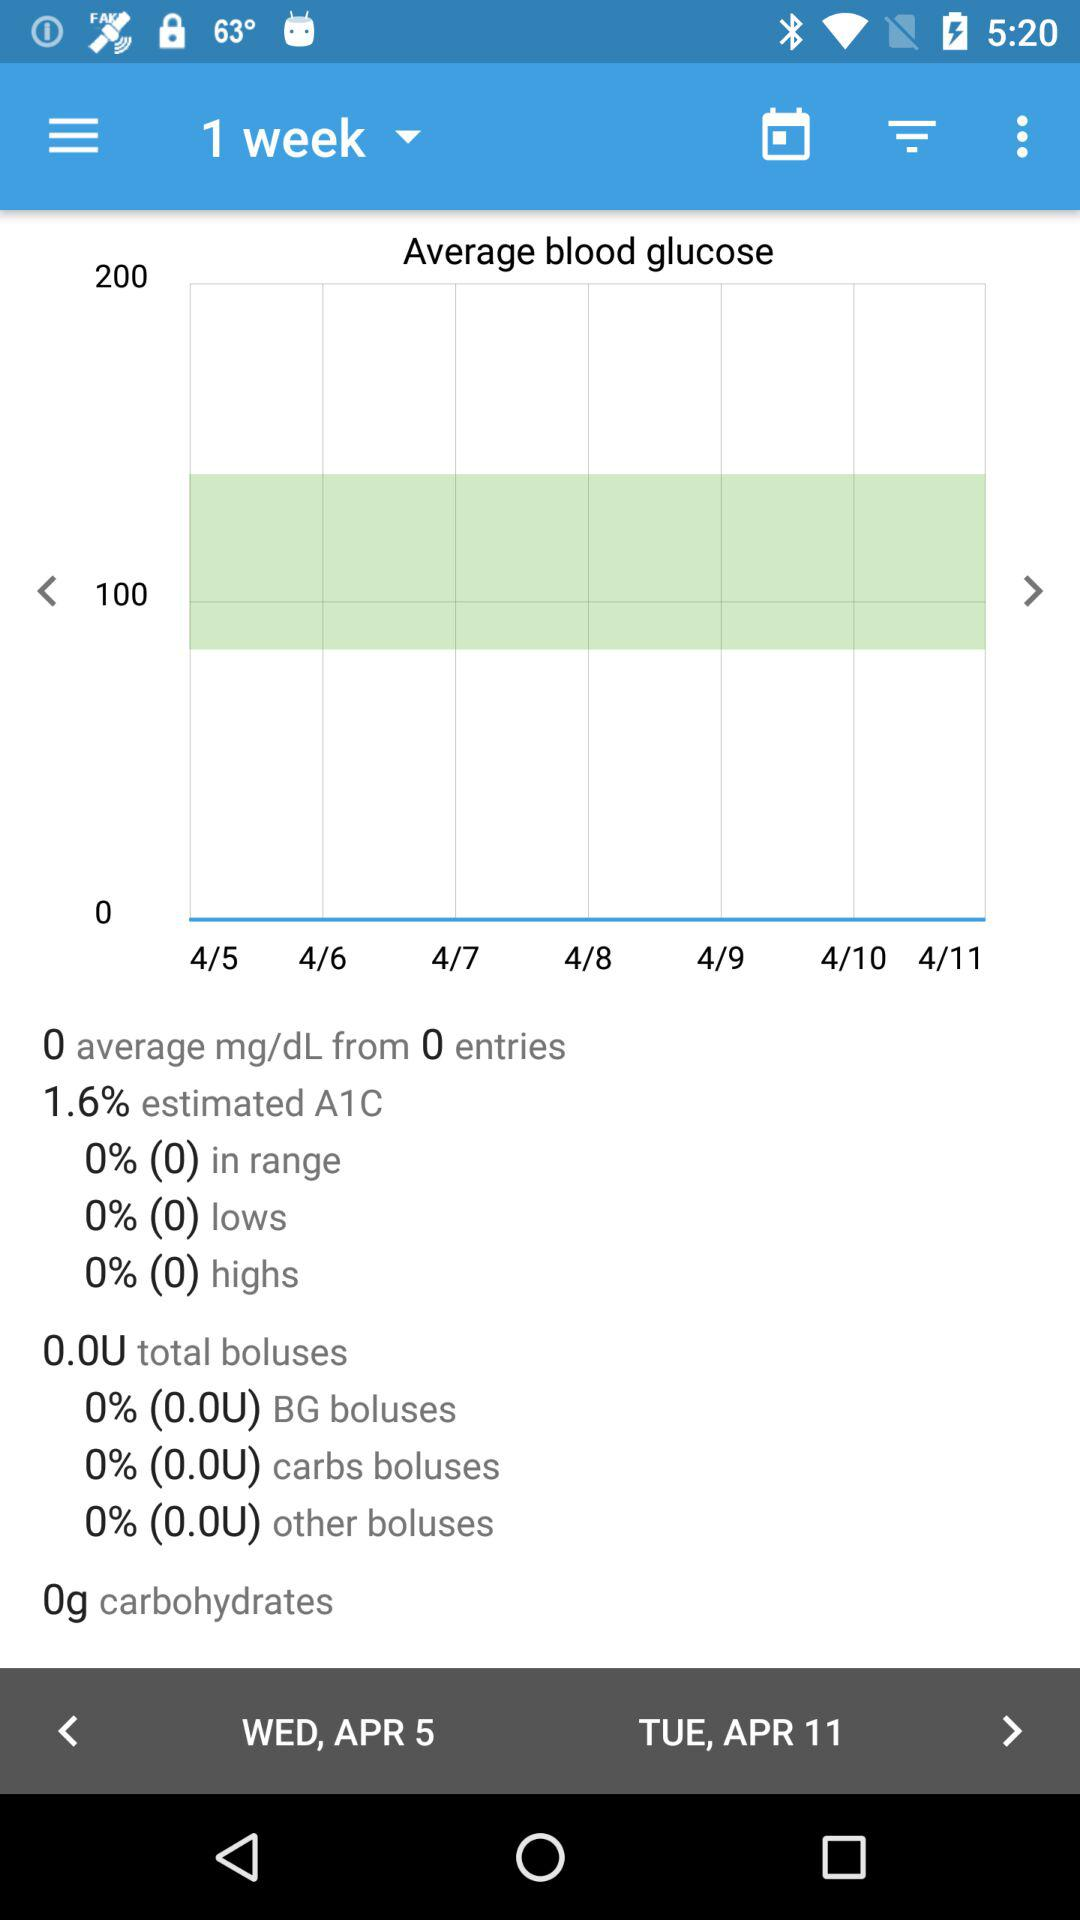How many entries are shown in the graph?
Answer the question using a single word or phrase. 0 